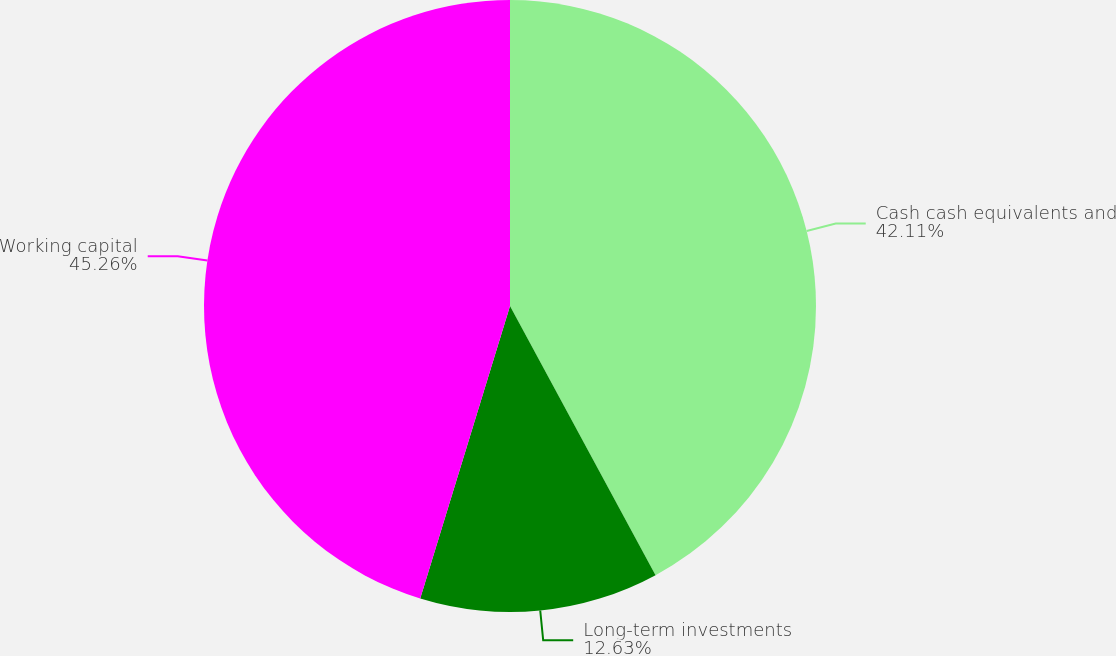<chart> <loc_0><loc_0><loc_500><loc_500><pie_chart><fcel>Cash cash equivalents and<fcel>Long-term investments<fcel>Working capital<nl><fcel>42.11%<fcel>12.63%<fcel>45.26%<nl></chart> 